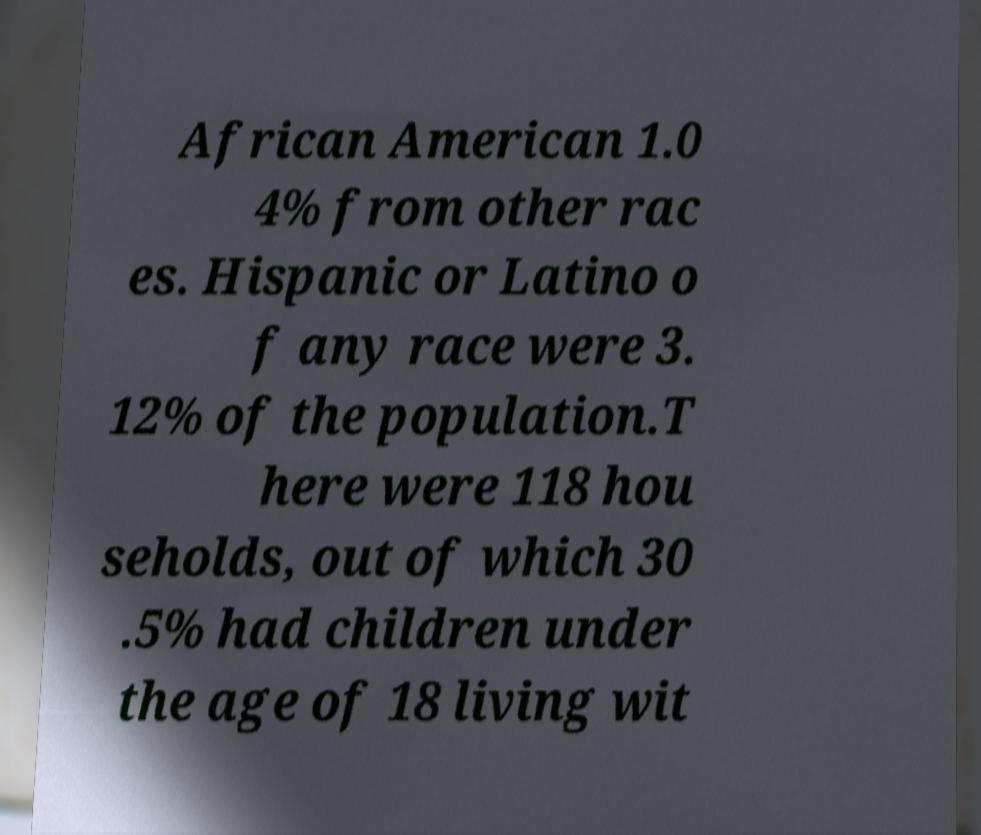Can you read and provide the text displayed in the image?This photo seems to have some interesting text. Can you extract and type it out for me? African American 1.0 4% from other rac es. Hispanic or Latino o f any race were 3. 12% of the population.T here were 118 hou seholds, out of which 30 .5% had children under the age of 18 living wit 